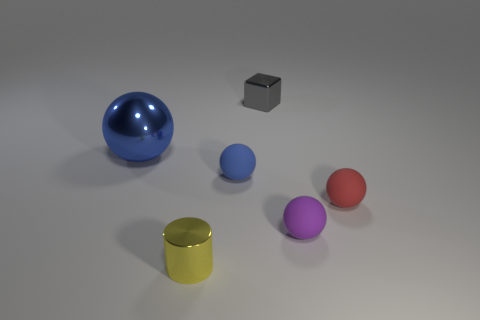Subtract all red cylinders. How many blue balls are left? 2 Subtract all small blue matte spheres. How many spheres are left? 3 Add 1 red rubber spheres. How many objects exist? 7 Subtract all red balls. How many balls are left? 3 Subtract all cylinders. How many objects are left? 5 Subtract all brown balls. Subtract all green cylinders. How many balls are left? 4 Subtract all gray blocks. Subtract all blue things. How many objects are left? 3 Add 4 gray metal cubes. How many gray metal cubes are left? 5 Add 6 brown metal balls. How many brown metal balls exist? 6 Subtract 0 yellow blocks. How many objects are left? 6 